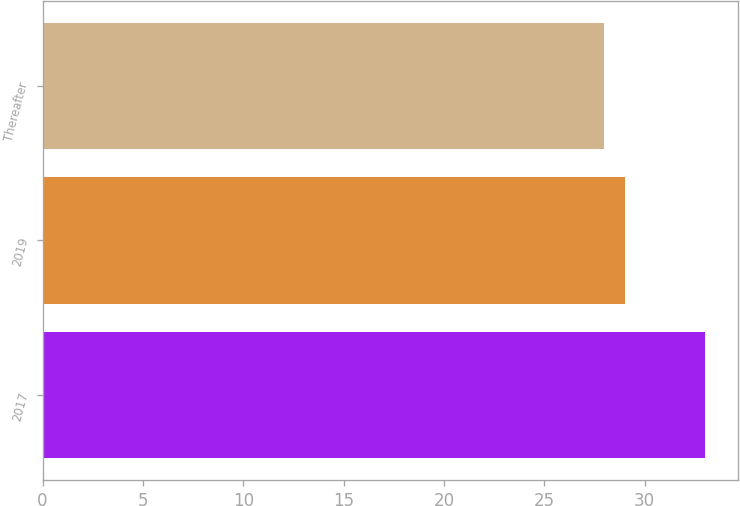Convert chart. <chart><loc_0><loc_0><loc_500><loc_500><bar_chart><fcel>2017<fcel>2019<fcel>Thereafter<nl><fcel>33<fcel>29<fcel>28<nl></chart> 